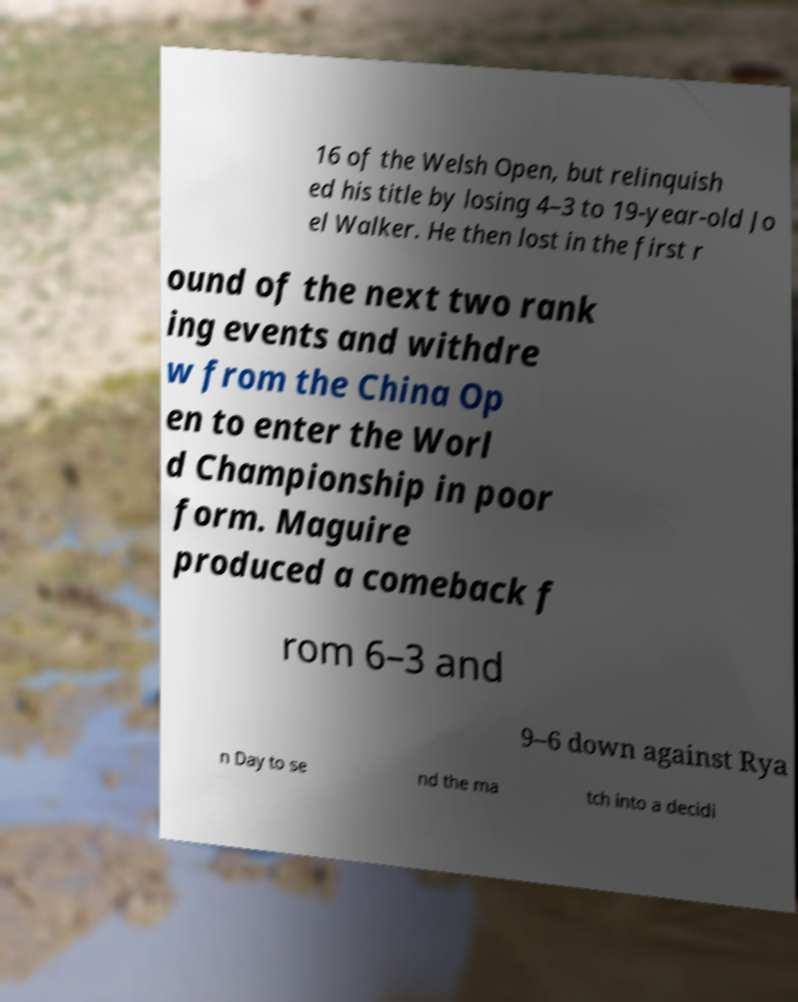For documentation purposes, I need the text within this image transcribed. Could you provide that? 16 of the Welsh Open, but relinquish ed his title by losing 4–3 to 19-year-old Jo el Walker. He then lost in the first r ound of the next two rank ing events and withdre w from the China Op en to enter the Worl d Championship in poor form. Maguire produced a comeback f rom 6–3 and 9–6 down against Rya n Day to se nd the ma tch into a decidi 